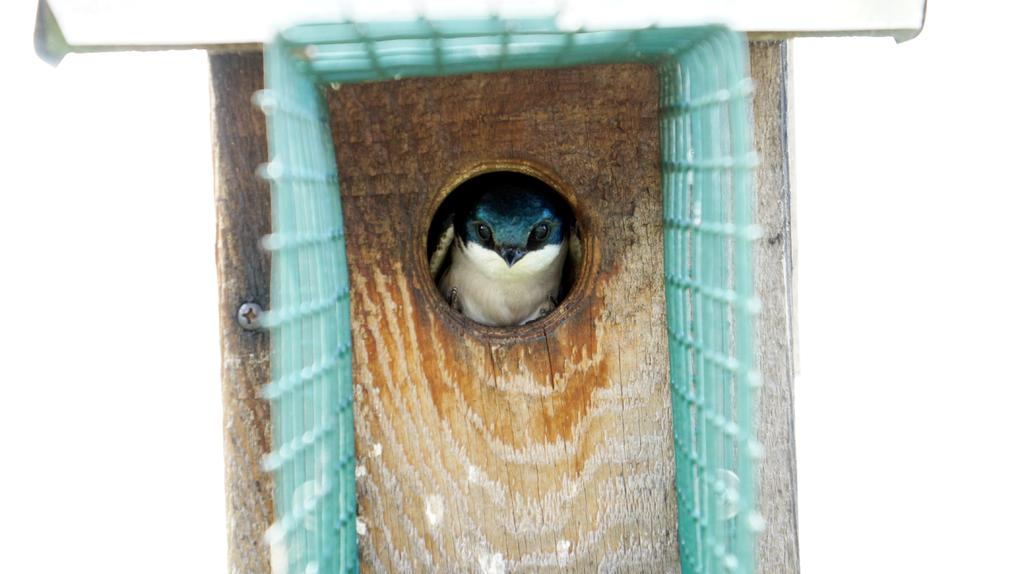What type of animal can be seen in the image? There is a bird in the image. Where is the bird located in the image? The bird is in the trunk of a tree. What is present in front of the bird in the image? There is a metal object in front of the bird. What type of fiction is the bird reading in the image? There is no indication in the image that the bird is reading any fiction, as birds do not read. 